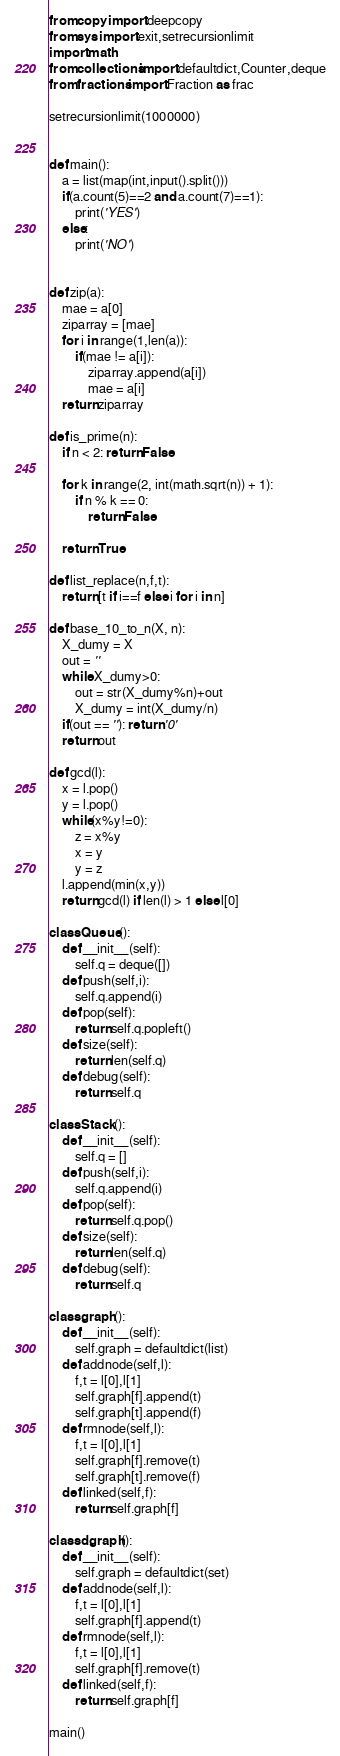Convert code to text. <code><loc_0><loc_0><loc_500><loc_500><_Python_>from copy import deepcopy
from sys import exit,setrecursionlimit
import math
from collections import defaultdict,Counter,deque
from fractions import Fraction as frac

setrecursionlimit(1000000)


def main():
	a = list(map(int,input().split()))
	if(a.count(5)==2 and a.count(7)==1):
		print('YES')
	else:
		print('NO')
	

def zip(a):
	mae = a[0]
	ziparray = [mae]
	for i in range(1,len(a)):
		if(mae != a[i]):
			ziparray.append(a[i])
			mae = a[i]
	return ziparray

def is_prime(n):
	if n < 2: return False

	for k in range(2, int(math.sqrt(n)) + 1):
		if n % k == 0:
			return False

	return True

def list_replace(n,f,t):
	return [t if i==f else i for i in n]

def base_10_to_n(X, n):
	X_dumy = X
	out = ''
	while X_dumy>0:
		out = str(X_dumy%n)+out
		X_dumy = int(X_dumy/n)
	if(out == ''): return '0'
	return out

def gcd(l):
	x = l.pop()
	y = l.pop()
	while(x%y!=0):
		z = x%y
		x = y
		y = z
	l.append(min(x,y))
	return gcd(l) if len(l) > 1 else l[0]

class Queue():
	def __init__(self):
		self.q = deque([])
	def push(self,i):
		self.q.append(i)
	def pop(self):
		return self.q.popleft()
	def size(self):
		return len(self.q)
	def debug(self):
		return self.q

class Stack():
	def __init__(self):
		self.q = []
	def push(self,i):
		self.q.append(i)
	def pop(self):
		return self.q.pop()
	def size(self):
		return len(self.q)
	def debug(self):
		return self.q

class graph():
	def __init__(self):
		self.graph = defaultdict(list)
	def addnode(self,l):
		f,t = l[0],l[1]
		self.graph[f].append(t)
		self.graph[t].append(f)
	def rmnode(self,l):
		f,t = l[0],l[1]
		self.graph[f].remove(t)
		self.graph[t].remove(f)
	def linked(self,f):
		return self.graph[f]

class dgraph():
	def __init__(self):
		self.graph = defaultdict(set)
	def addnode(self,l):
		f,t = l[0],l[1]
		self.graph[f].append(t)
	def rmnode(self,l):
		f,t = l[0],l[1]
		self.graph[f].remove(t)
	def linked(self,f):
		return self.graph[f]

main()
</code> 